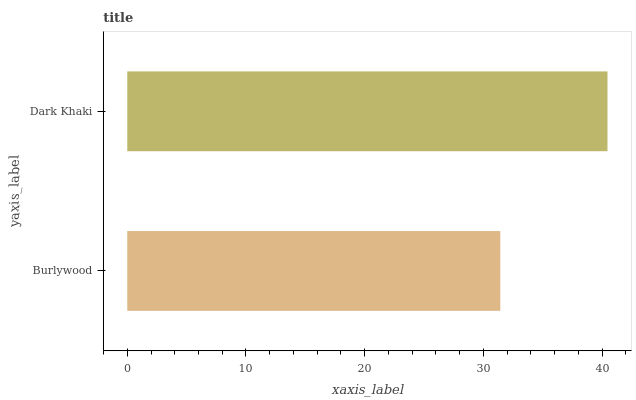Is Burlywood the minimum?
Answer yes or no. Yes. Is Dark Khaki the maximum?
Answer yes or no. Yes. Is Dark Khaki the minimum?
Answer yes or no. No. Is Dark Khaki greater than Burlywood?
Answer yes or no. Yes. Is Burlywood less than Dark Khaki?
Answer yes or no. Yes. Is Burlywood greater than Dark Khaki?
Answer yes or no. No. Is Dark Khaki less than Burlywood?
Answer yes or no. No. Is Dark Khaki the high median?
Answer yes or no. Yes. Is Burlywood the low median?
Answer yes or no. Yes. Is Burlywood the high median?
Answer yes or no. No. Is Dark Khaki the low median?
Answer yes or no. No. 